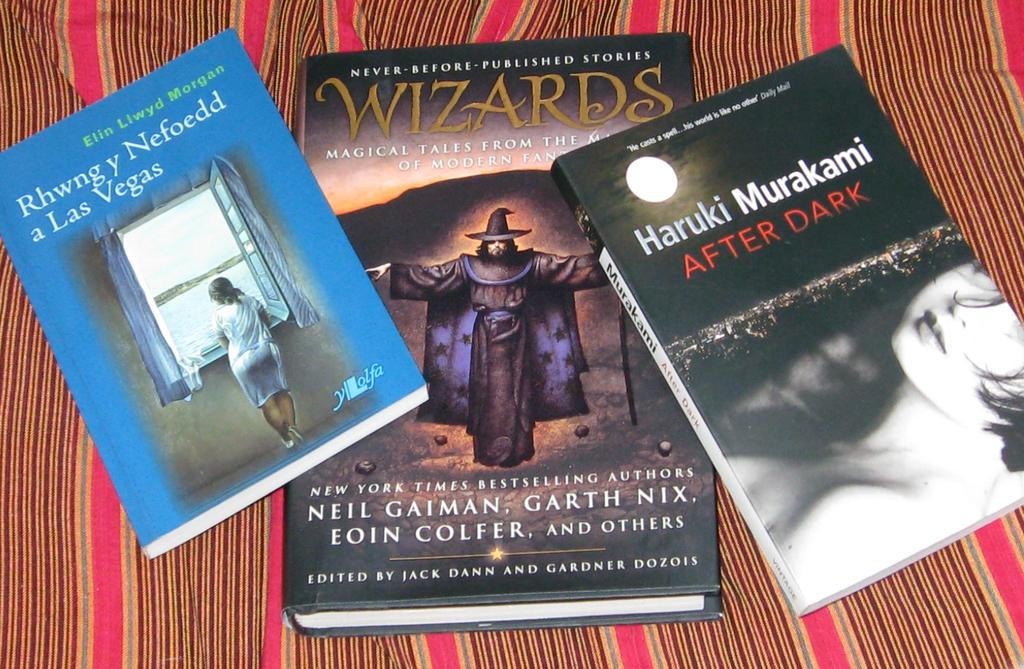<image>
Create a compact narrative representing the image presented. Three books which include Haruki Murakami After Dark, Wizards, and Rhwng y Nefoedd a Las Vegas. 